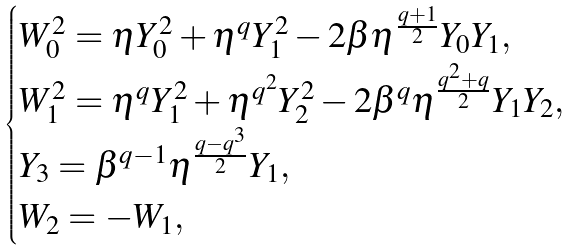Convert formula to latex. <formula><loc_0><loc_0><loc_500><loc_500>\begin{cases} W _ { 0 } ^ { 2 } = \eta Y _ { 0 } ^ { 2 } + \eta ^ { q } Y _ { 1 } ^ { 2 } - 2 \beta \eta ^ { \frac { q + 1 } { 2 } } Y _ { 0 } Y _ { 1 } , \\ W _ { 1 } ^ { 2 } = \eta ^ { q } Y _ { 1 } ^ { 2 } + \eta ^ { q ^ { 2 } } Y _ { 2 } ^ { 2 } - 2 \beta ^ { q } \eta ^ { \frac { q ^ { 2 } + q } { 2 } } Y _ { 1 } Y _ { 2 } , \\ Y _ { 3 } = \beta ^ { q - 1 } \eta ^ { \frac { q - q ^ { 3 } } { 2 } } Y _ { 1 } , \\ W _ { 2 } = - W _ { 1 } , \\ \end{cases}</formula> 